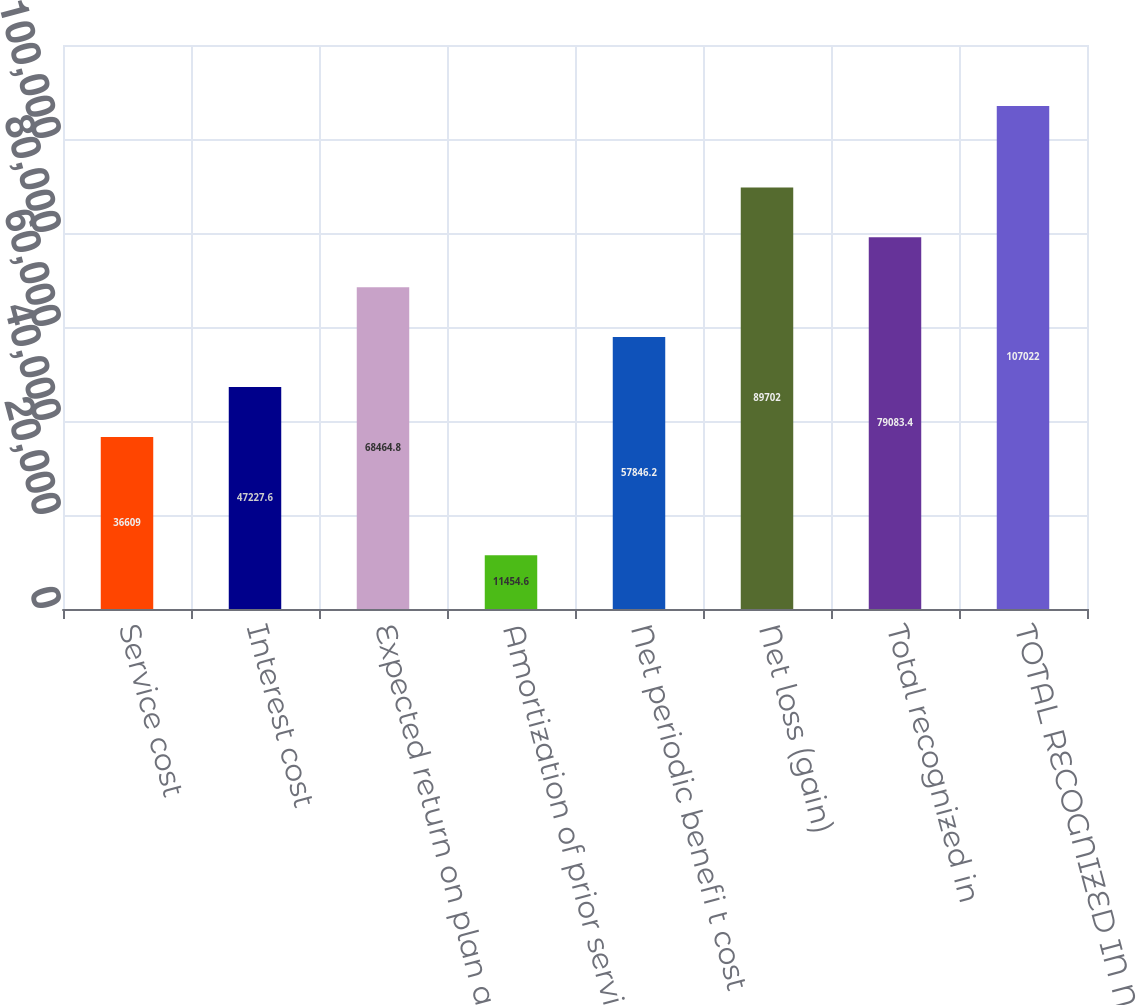Convert chart to OTSL. <chart><loc_0><loc_0><loc_500><loc_500><bar_chart><fcel>Service cost<fcel>Interest cost<fcel>Expected return on plan assets<fcel>Amortization of prior service<fcel>Net periodic benefi t cost<fcel>Net loss (gain)<fcel>Total recognized in<fcel>TOTAL RECOGNIZED IN NET<nl><fcel>36609<fcel>47227.6<fcel>68464.8<fcel>11454.6<fcel>57846.2<fcel>89702<fcel>79083.4<fcel>107022<nl></chart> 